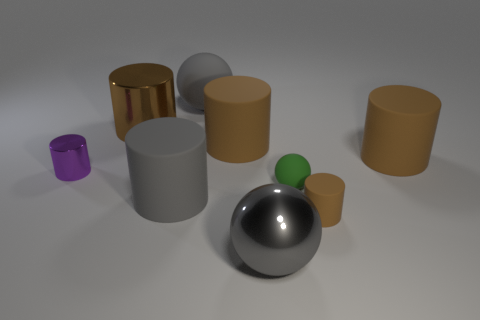Subtract all tiny balls. How many balls are left? 2 Subtract all spheres. How many objects are left? 6 Subtract all brown cylinders. How many gray balls are left? 2 Subtract all big gray metallic objects. Subtract all small metal cylinders. How many objects are left? 7 Add 7 tiny green spheres. How many tiny green spheres are left? 8 Add 9 small yellow matte cubes. How many small yellow matte cubes exist? 9 Subtract all gray spheres. How many spheres are left? 1 Subtract 0 blue cubes. How many objects are left? 9 Subtract 2 cylinders. How many cylinders are left? 4 Subtract all red spheres. Subtract all purple blocks. How many spheres are left? 3 